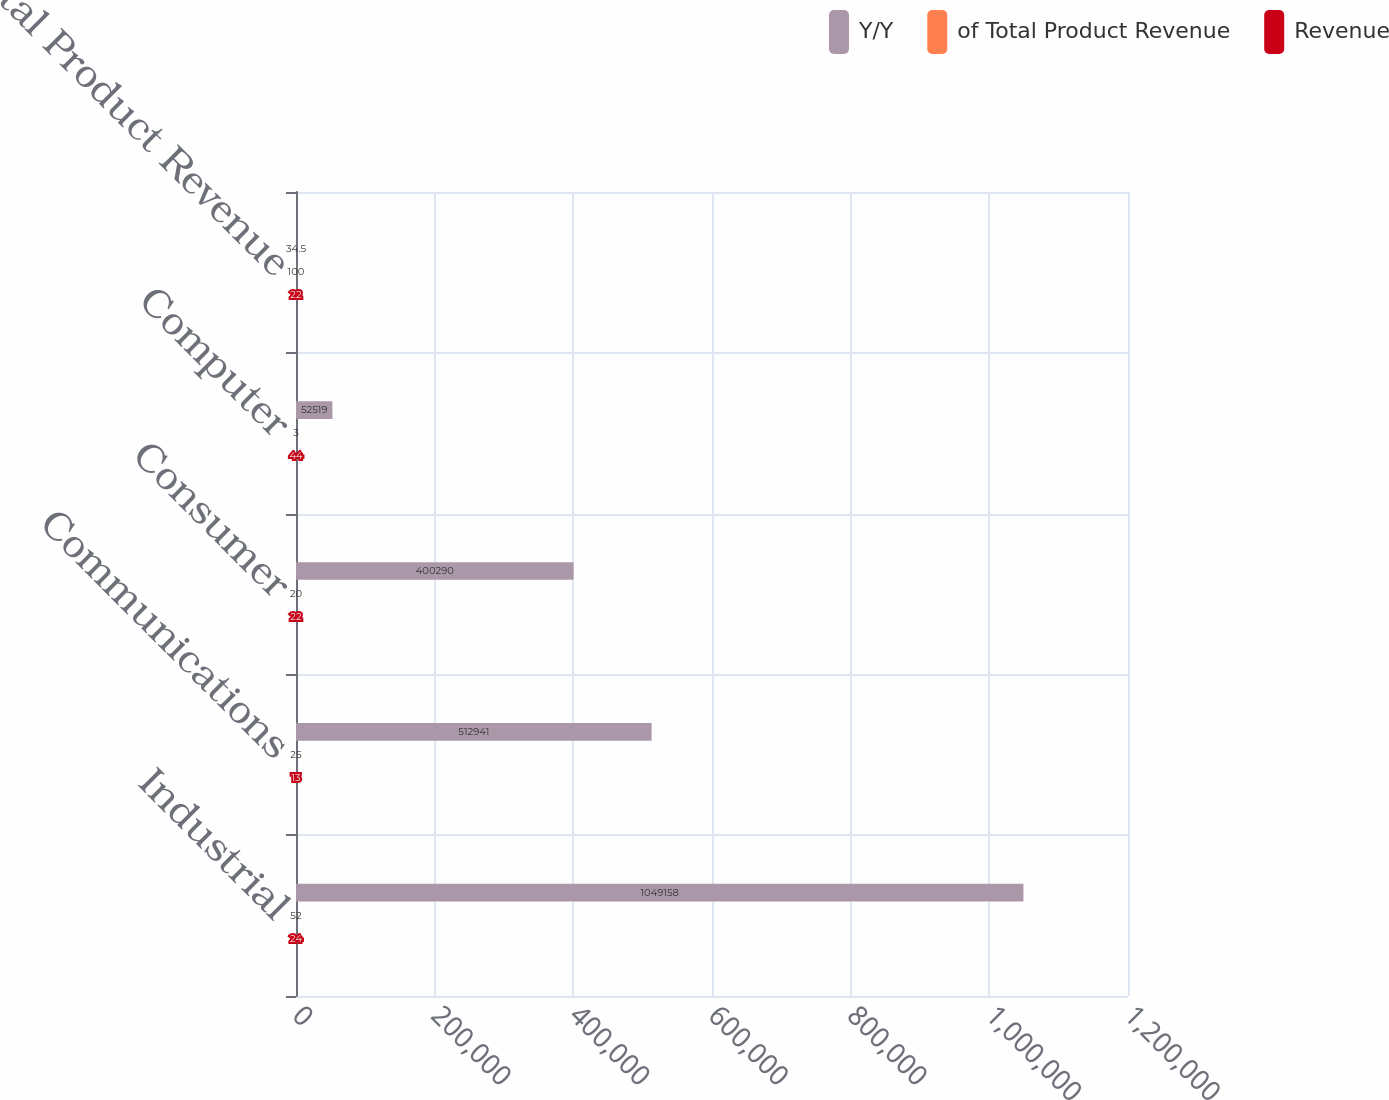<chart> <loc_0><loc_0><loc_500><loc_500><stacked_bar_chart><ecel><fcel>Industrial<fcel>Communications<fcel>Consumer<fcel>Computer<fcel>Total Product Revenue<nl><fcel>Y/Y<fcel>1.04916e+06<fcel>512941<fcel>400290<fcel>52519<fcel>34.5<nl><fcel>of Total Product Revenue<fcel>52<fcel>25<fcel>20<fcel>3<fcel>100<nl><fcel>Revenue<fcel>24<fcel>13<fcel>22<fcel>44<fcel>22<nl></chart> 